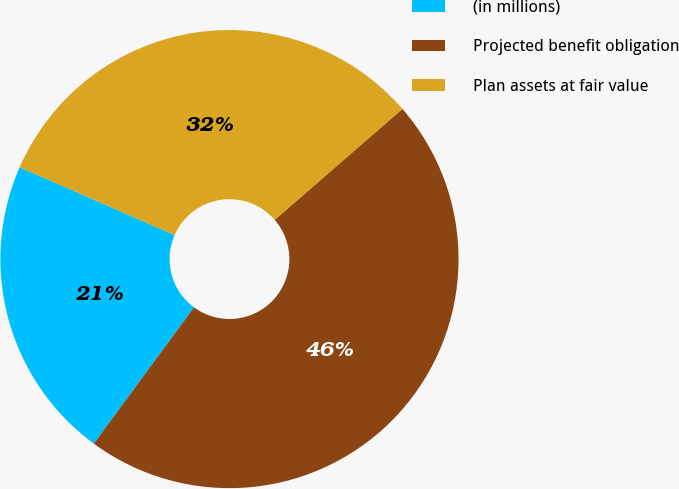Convert chart. <chart><loc_0><loc_0><loc_500><loc_500><pie_chart><fcel>(in millions)<fcel>Projected benefit obligation<fcel>Plan assets at fair value<nl><fcel>21.48%<fcel>46.47%<fcel>32.05%<nl></chart> 